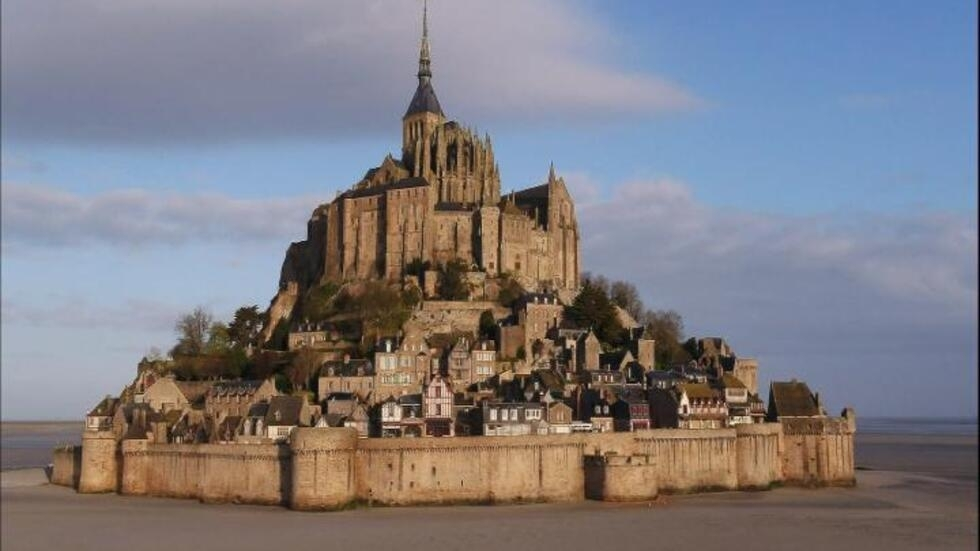What is this photo about? The image captures the breathtaking view of Mont St Michel, a renowned landmark in France. The photograph is taken from a distance, allowing the viewer to appreciate the entirety of the island and the surrounding water. Dominating the island is a large, medieval abbey, its tall spire reaching towards the sky. The abbey is encircled by a fortified wall, providing a glimpse into the past. Nestled within these fortifications is a small village, adding a touch of life to the historical monument. The color palette of the image is primarily earth tones, creating a harmonious blend with the blue hues of the sky and water. The perspective of the image offers a comprehensive view of this magnificent landmark, from its architectural grandeur to its natural surroundings. The image is a testament to the timeless beauty of Mont St Michel. 